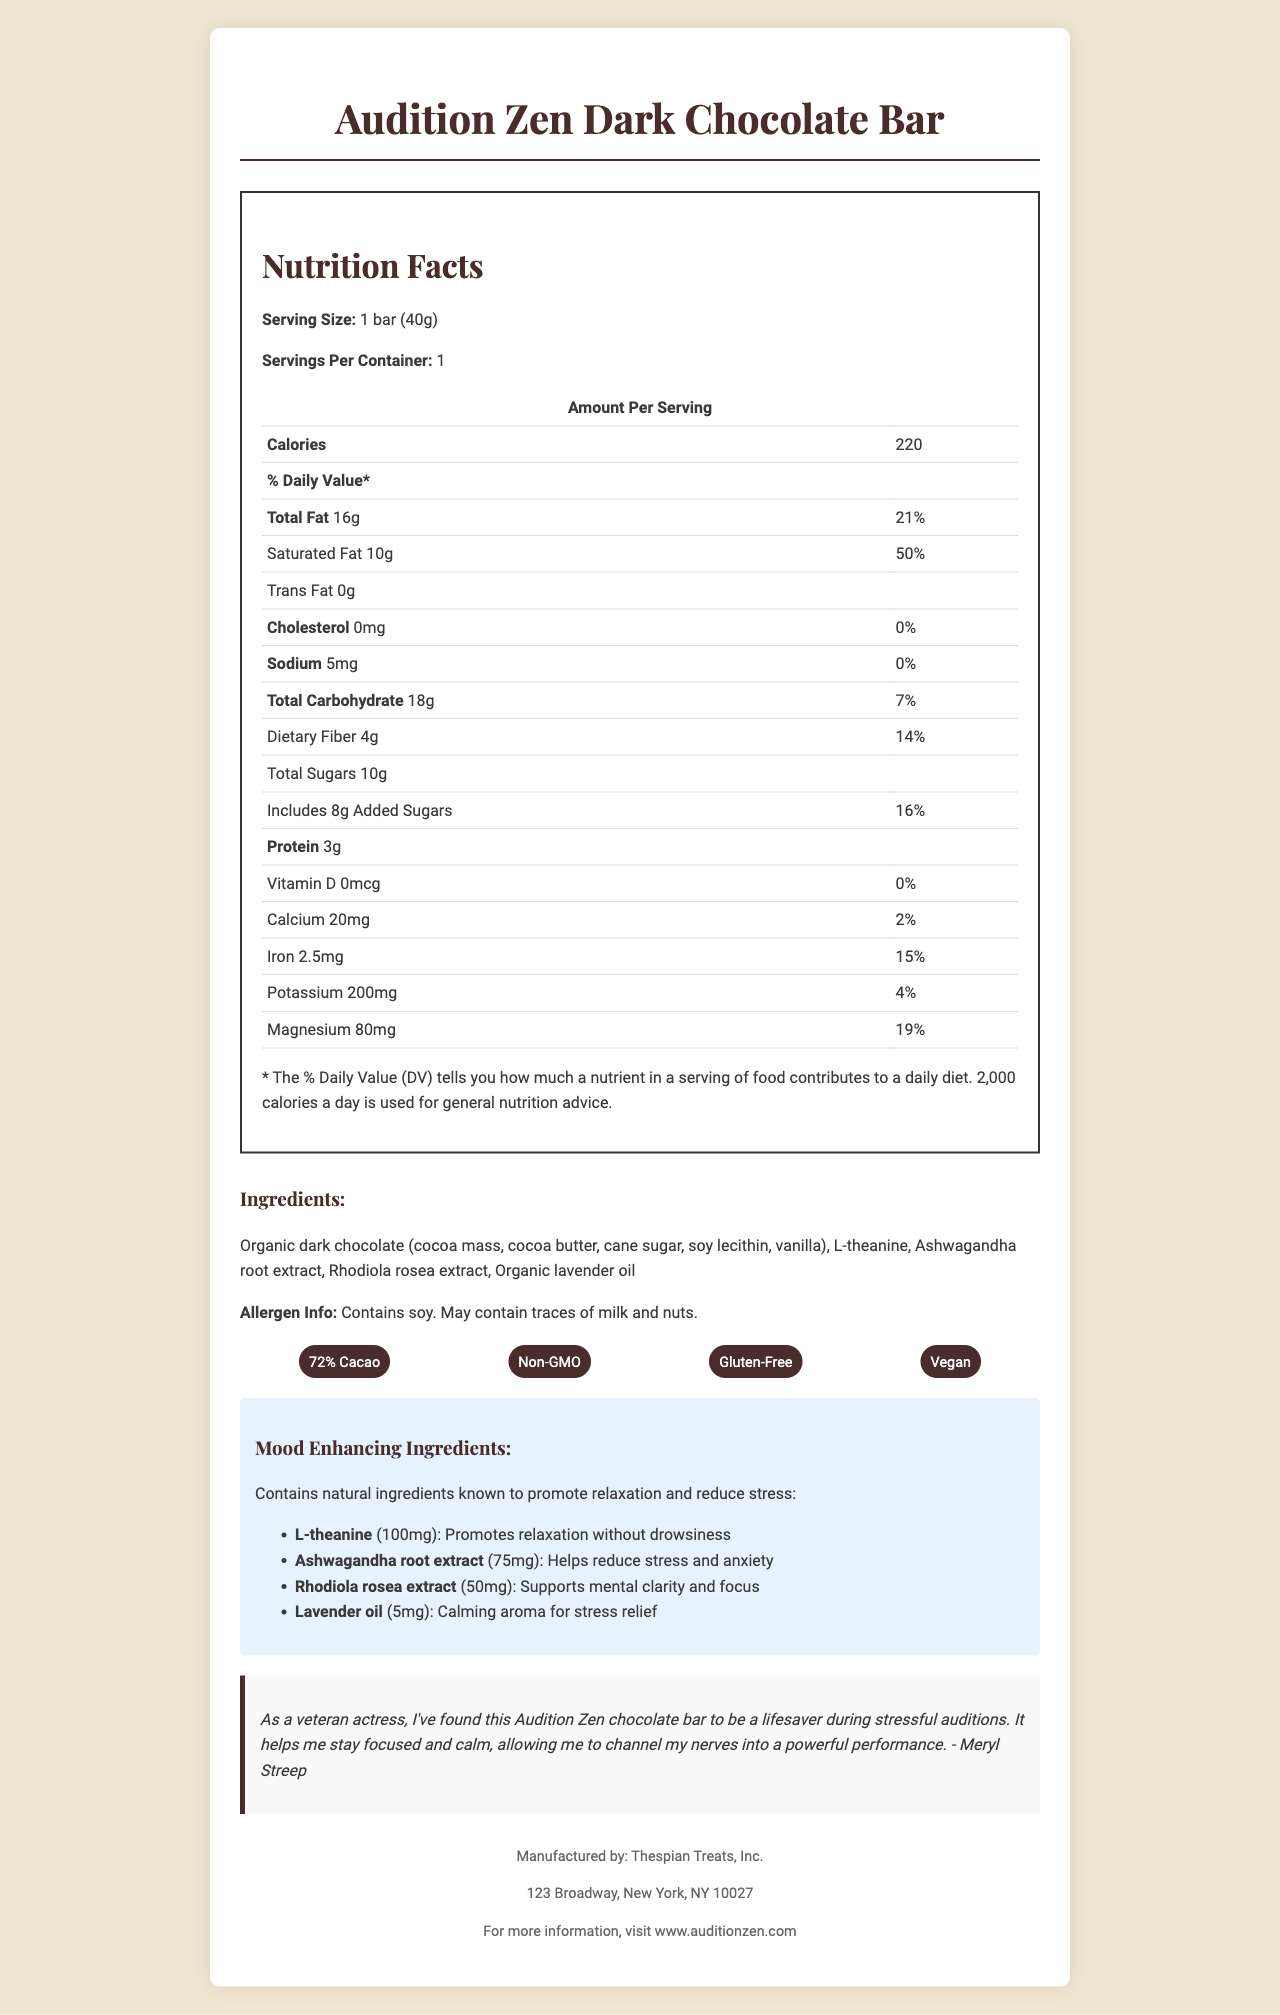what is the total fat content per serving? The document lists the total fat content as "Total Fat: 16g" under the nutrition facts section.
Answer: 16g what percentage of the daily value of saturated fat does one serving contain? The saturated fat percentage of the daily value is specified as "Saturated Fat 10g 50%".
Answer: 50% does the dark chocolate bar contain any cholesterol? The document states "Cholesterol 0mg 0%", indicating there is no cholesterol in the product.
Answer: No how much calcium is in one serving? The amount of calcium per serving is listed as "Calcium 20mg 2%".
Answer: 20mg what is the primary source of dietary fiber in this chocolate bar? Based on the ingredients listed, the primary source of dietary fiber is likely the "organic dark chocolate".
Answer: Organic dark chocolate which mood-enhancing ingredient is in the largest quantity? A. L-theanine B. Ashwagandha root extract C. Rhodiola rosea extract D. Lavender oil The chart for mood-enhancing ingredients indicates "L-theanine 100mg" which is the largest amount among the listed ingredients.
Answer: A. L-theanine what is the main benefit of Ashwagandha root extract in this product? A. Promotes relaxation without drowsiness B. Helps reduce stress and anxiety C. Supports mental clarity and focus D. Calming aroma for stress relief The document specifies Ashwagandha root extract’s benefit as "Helps reduce stress and anxiety."
Answer: B. Helps reduce stress and anxiety can this chocolate bar be consumed by someone with gluten intolerance? The document includes "Gluten-Free" under the special features section, indicating it can be consumed by someone with gluten intolerance.
Answer: Yes describe the main features and benefits of the Audition Zen Dark Chocolate Bar. The document includes details about the nutritional content, ingredients, mood-enhancing properties, and special features, along with a testimonial from Meryl Streep.
Answer: The Audition Zen Dark Chocolate Bar is a specialty dark chocolate designed for stress relief, particularly suitable for actors during auditions. It contains ingredients like organic dark chocolate, L-theanine, ashwagandha root extract, rhodiola rosea extract, and organic lavender oil. The bar is gluten-free, vegan, and non-GMO. Each serving provides 220 calories, 16g of total fat, and various nutrients like calcium and magnesium. The product also highlights its mood-enhancing properties, such as reducing stress and promoting relaxation. Actor Meryl Streep endorses it for helping her stay calm and focused during auditions. who is the manufacturer of this dark chocolate bar? The document mentions "Manufactured by: Thespian Treats, Inc." in the footer section.
Answer: Thespian Treats, Inc. how many servings are in one container? The document lists "Servings Per Container: 1" in the nutrition facts section.
Answer: 1 who endorsed the Audition Zen Dark Chocolate Bar and what did they say? The endorsement from Meryl Streep is included in the document under the testimonial section.
Answer: Meryl Streep, who stated it helps her stay focused and calm during stressful auditions, allowing her to channel her nerves into a powerful performance. what is the total carbohydrate content per serving and its daily value percentage? The document lists total carbohydrates as "Total Carbohydrate 18g 7%" under the nutrition facts section.
Answer: 18g, 7% is there any vitamin D in this chocolate bar? The document states "Vitamin D 0mcg 0%" indicating there is no vitamin D in the product.
Answer: No which mood-enhancing ingredient supports mental clarity and focus? The document lists Rhodiola rosea extract with the benefit "Supports mental clarity and focus."
Answer: Rhodiola rosea extract what is the amount of potassium in the chocolate bar? The amount of potassium per serving is listed as "Potassium 200mg 4%" in the nutrition facts section.
Answer: 200mg how many grams of added sugars are in one serving? The nutrition facts state "Includes 8g Added Sugars 16%."
Answer: 8g what is the main purpose of the Audition Zen Dark Chocolate Bar? The document emphasizes the product's role in providing relaxation and stress relief during auditions, as highlighted by the mood-enhancing ingredients and testimonial.
Answer: The main purpose is to help actors stay focused and calm during stressful auditions by offering a combination of dark chocolate and mood-enhancing ingredients. how much protein is in one serving? The document lists the protein content as "Protein 3g" in the nutrition facts section.
Answer: 3g is this chocolate bar non-GMO? The document describes the product as "Non-GMO" under the special features section.
Answer: Yes what potent antioxidant is inherent in dark chocolate and often highlighted on dark chocolate labels, but not mentioned specifically in this document? The document does not mention any specific antioxidants, so the answer cannot be determined based on the provided information.
Answer: Cannot be determined 